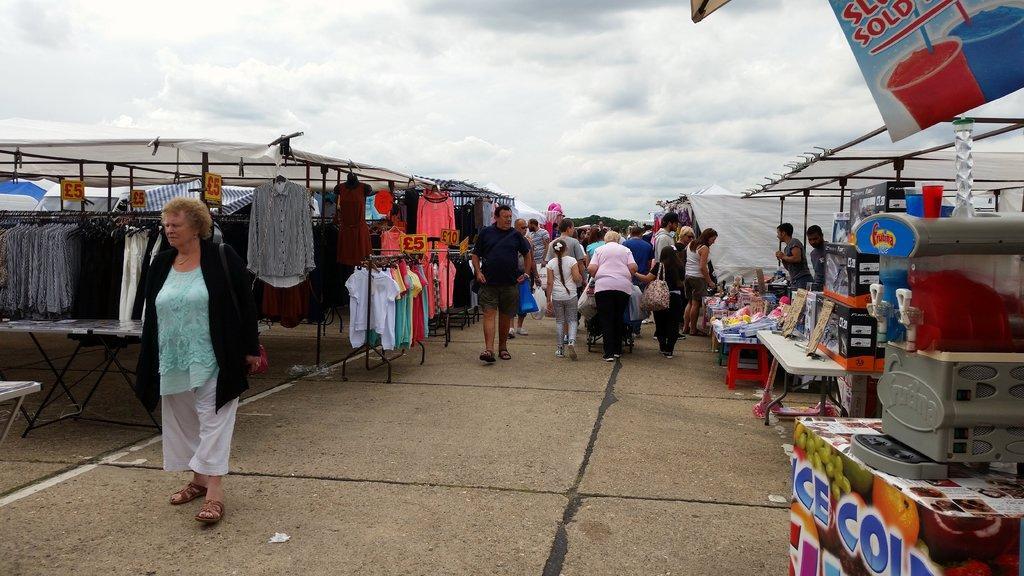Can you describe this image briefly? In this image we can see a few people, there are some tents, also we can see some clothes hanged to the hangers, there are some tables, on the tables, we can see the boxes, machine, and some other objects, there are some trees and price boards, in the background, we can see the sky with clouds. 